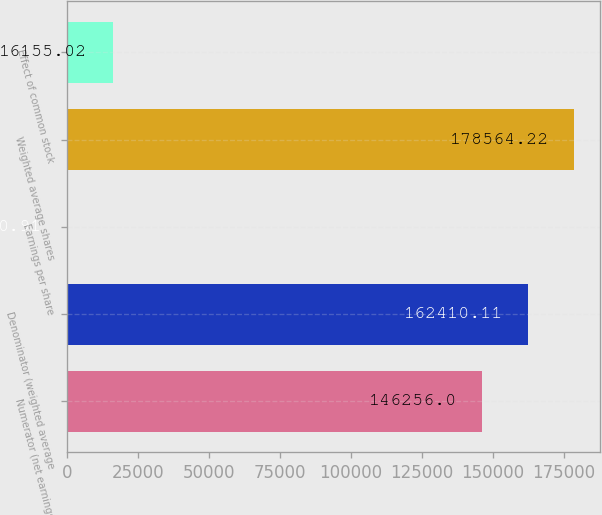<chart> <loc_0><loc_0><loc_500><loc_500><bar_chart><fcel>Numerator (net earnings)<fcel>Denominator (weighted average<fcel>Earnings per share<fcel>Weighted average shares<fcel>Effect of common stock<nl><fcel>146256<fcel>162410<fcel>0.91<fcel>178564<fcel>16155<nl></chart> 